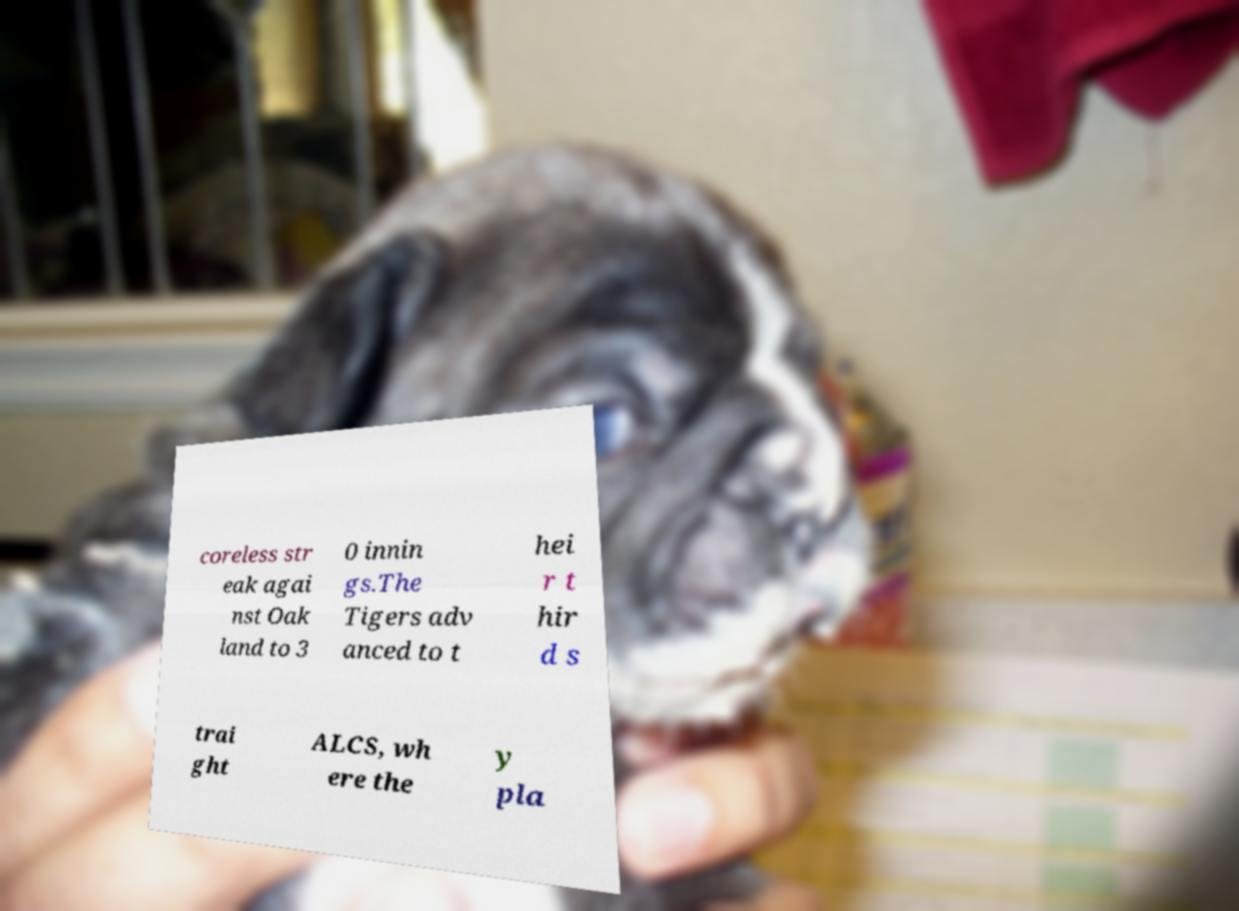Could you extract and type out the text from this image? coreless str eak agai nst Oak land to 3 0 innin gs.The Tigers adv anced to t hei r t hir d s trai ght ALCS, wh ere the y pla 